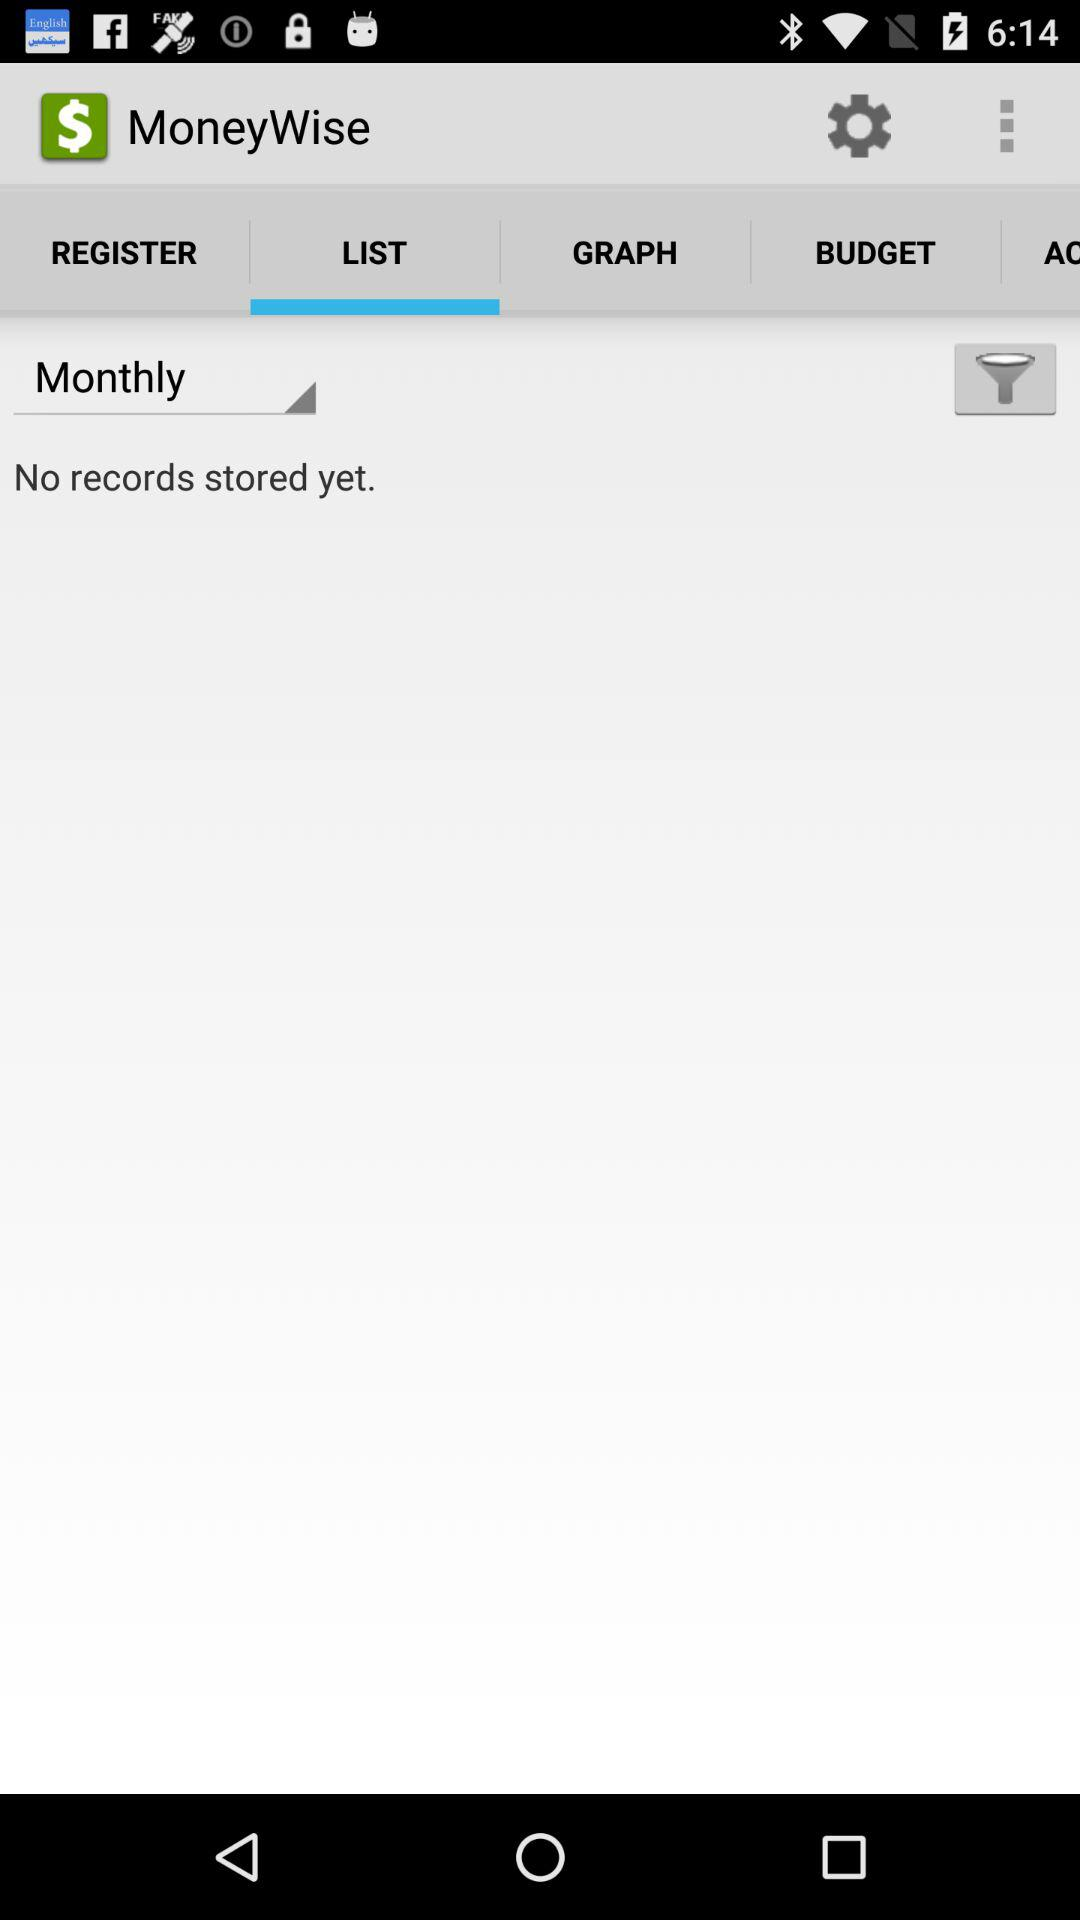Which tab of "MoneyWise" am I on? You are on the "LIST" tab. 